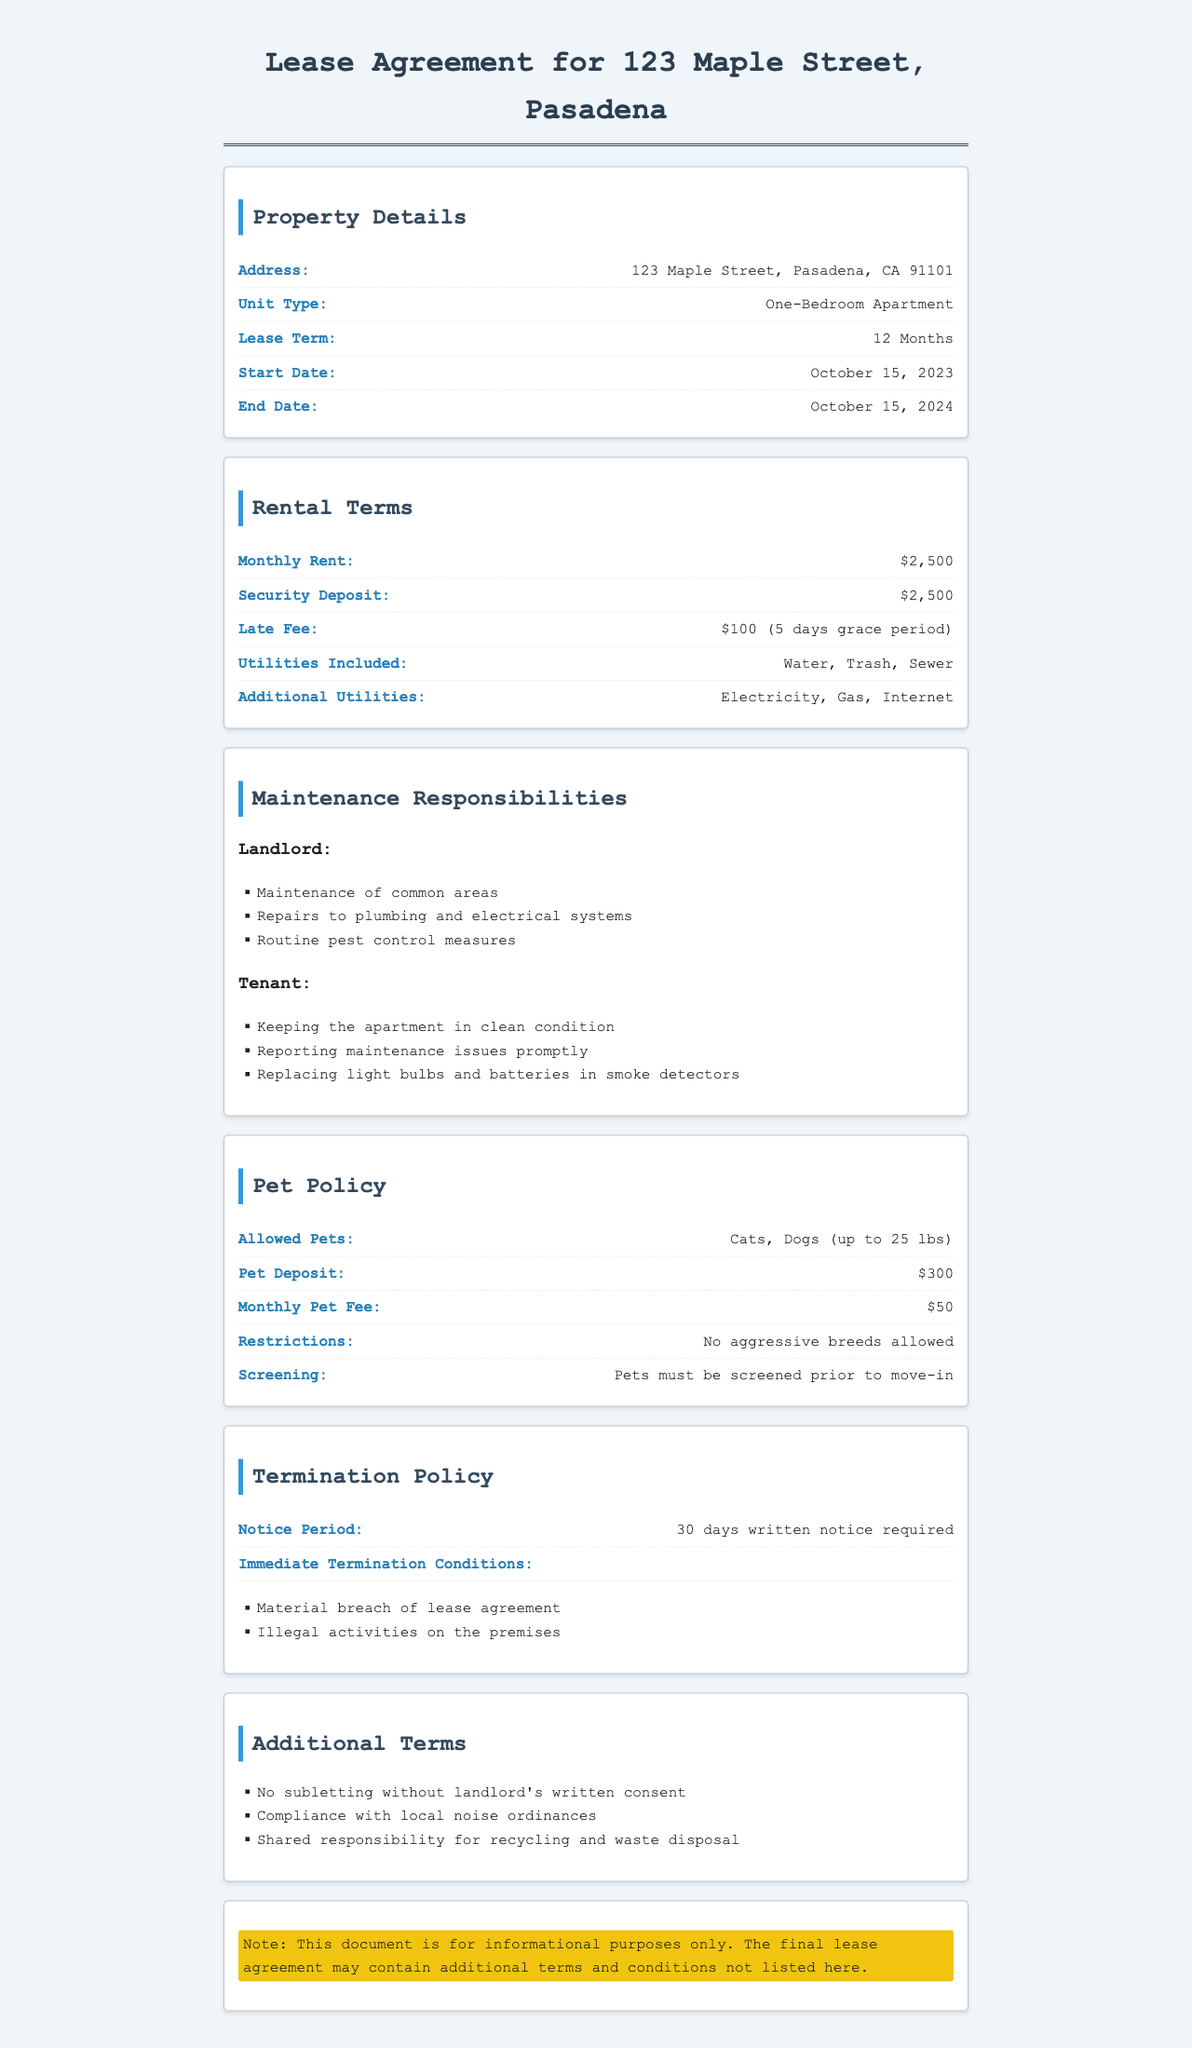What is the lease term? The lease term is explicitly stated in the document, indicating the duration of the lease agreement.
Answer: 12 Months What is the monthly rent amount? The document specifies the monthly rent for the apartment clearly.
Answer: $2,500 What is the pet deposit? The document includes information about the pet deposit required for having pets in the apartment.
Answer: $300 What type of pets are allowed? The document lists the types of pets that can be kept in the apartment, including weight restrictions.
Answer: Cats, Dogs (up to 25 lbs) What is the notice period for termination? The lease agreement discusses the notice period that must be given to terminate the lease.
Answer: 30 days written notice required Who is responsible for replacing light bulbs? The responsibilities are divided between the landlord and tenant in the document, specifying who handles certain tasks.
Answer: Tenant What is the late fee amount? A specific fee for late rental payments is mentioned in the rental terms section.
Answer: $100 (5 days grace period) What is required before pets can move in? The pet policy outlines the procedures that must be followed regarding pets living in the apartment.
Answer: Pets must be screened prior to move-in Are there any subletting restrictions? The document outlines restrictions regarding subletting the apartment.
Answer: No subletting without landlord's written consent 